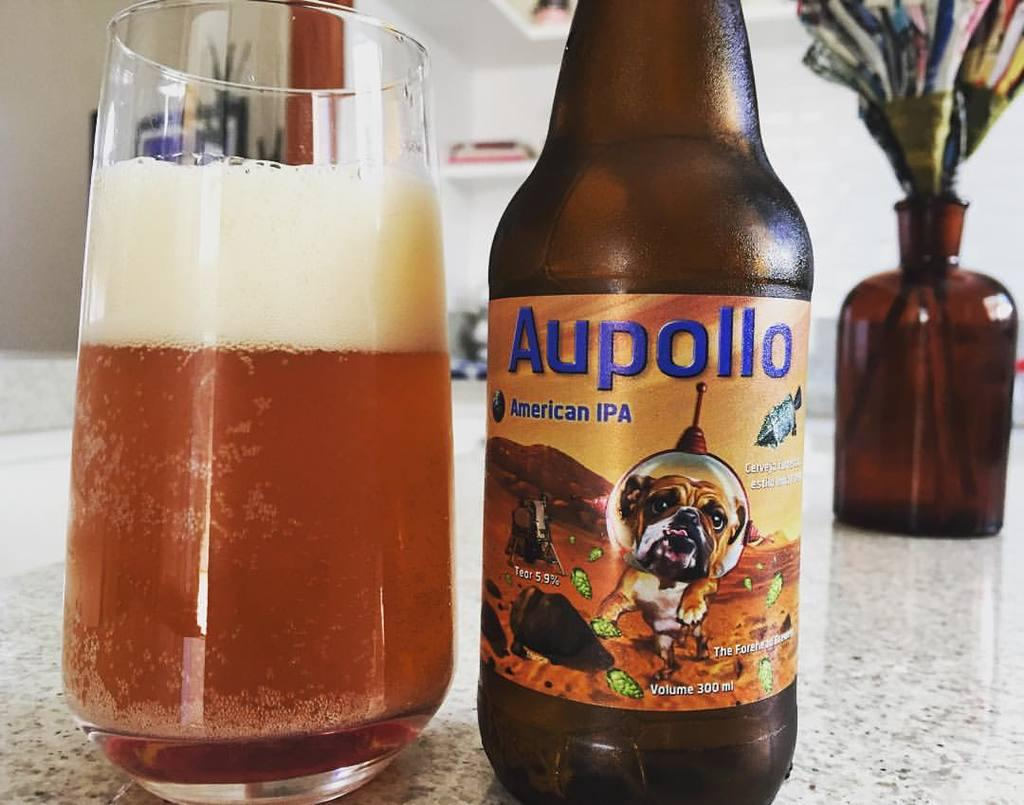<image>
Relay a brief, clear account of the picture shown. A glass cup full of Aupollo that is in a jar next to it on a counter with flowers in a vase in the background. 